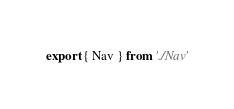<code> <loc_0><loc_0><loc_500><loc_500><_JavaScript_>export { Nav } from './Nav'</code> 